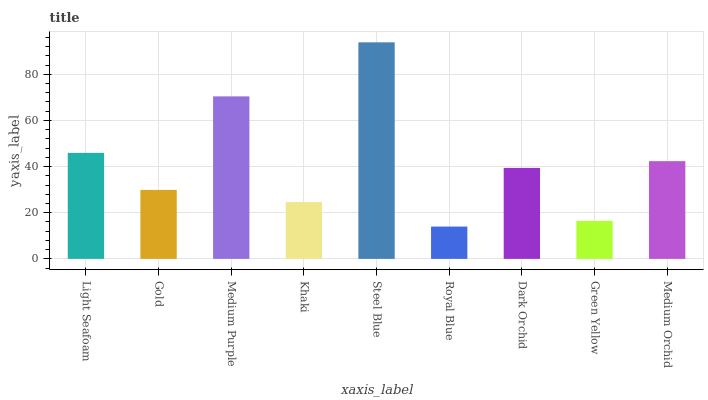Is Royal Blue the minimum?
Answer yes or no. Yes. Is Steel Blue the maximum?
Answer yes or no. Yes. Is Gold the minimum?
Answer yes or no. No. Is Gold the maximum?
Answer yes or no. No. Is Light Seafoam greater than Gold?
Answer yes or no. Yes. Is Gold less than Light Seafoam?
Answer yes or no. Yes. Is Gold greater than Light Seafoam?
Answer yes or no. No. Is Light Seafoam less than Gold?
Answer yes or no. No. Is Dark Orchid the high median?
Answer yes or no. Yes. Is Dark Orchid the low median?
Answer yes or no. Yes. Is Light Seafoam the high median?
Answer yes or no. No. Is Steel Blue the low median?
Answer yes or no. No. 